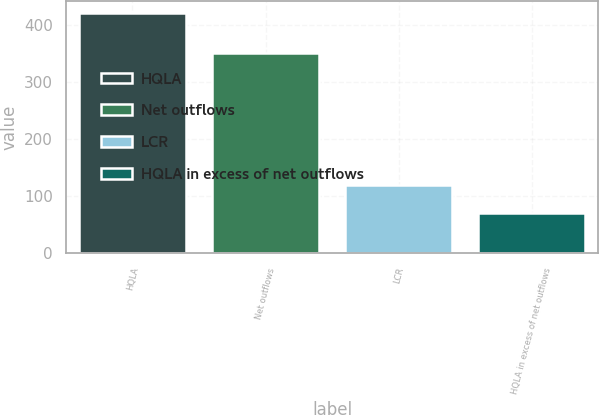<chart> <loc_0><loc_0><loc_500><loc_500><bar_chart><fcel>HQLA<fcel>Net outflows<fcel>LCR<fcel>HQLA in excess of net outflows<nl><fcel>420.8<fcel>350.8<fcel>120<fcel>70<nl></chart> 